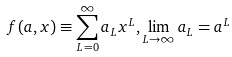Convert formula to latex. <formula><loc_0><loc_0><loc_500><loc_500>f ( a , x ) \equiv \sum _ { L = 0 } ^ { \infty } a _ { L } x ^ { L } , \lim _ { L \to \infty } a _ { L } = a ^ { L }</formula> 